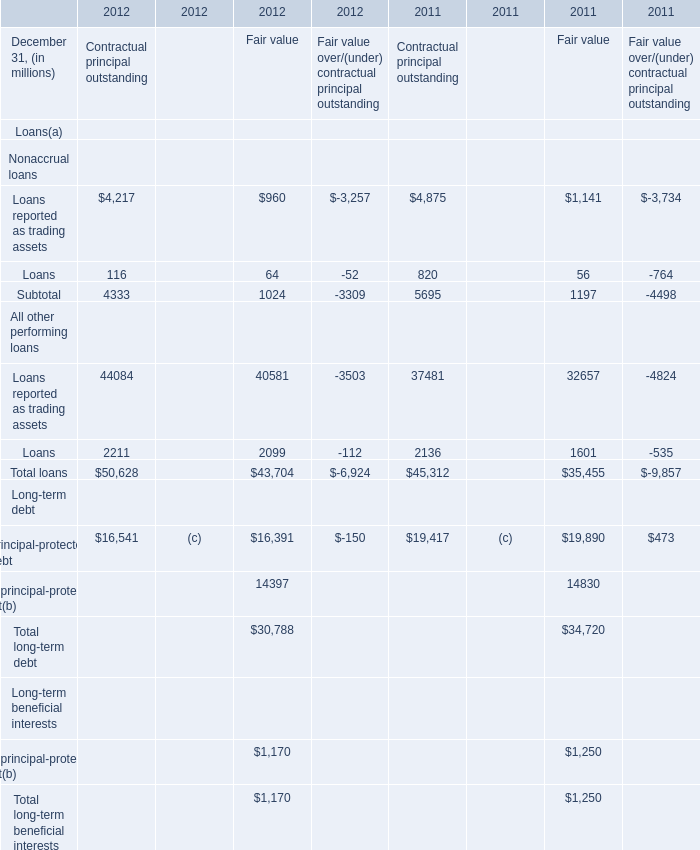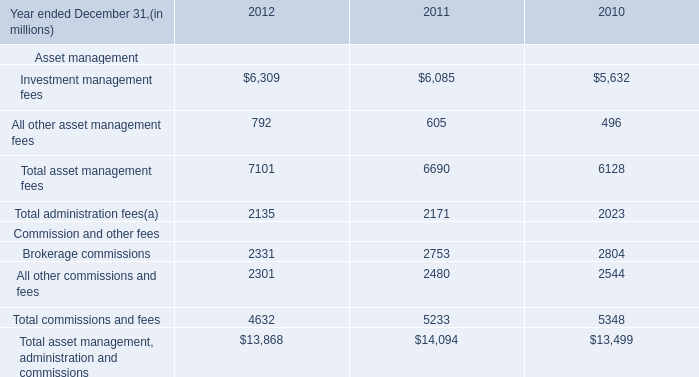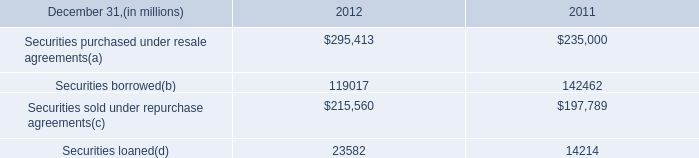What's the sum of Loans All other performing loans of 2012 Contractual principal outstanding, Securities loaned of 2011, and Total asset management fees of 2010 ? 
Computations: ((2211.0 + 14214.0) + 6128.0)
Answer: 22553.0. 